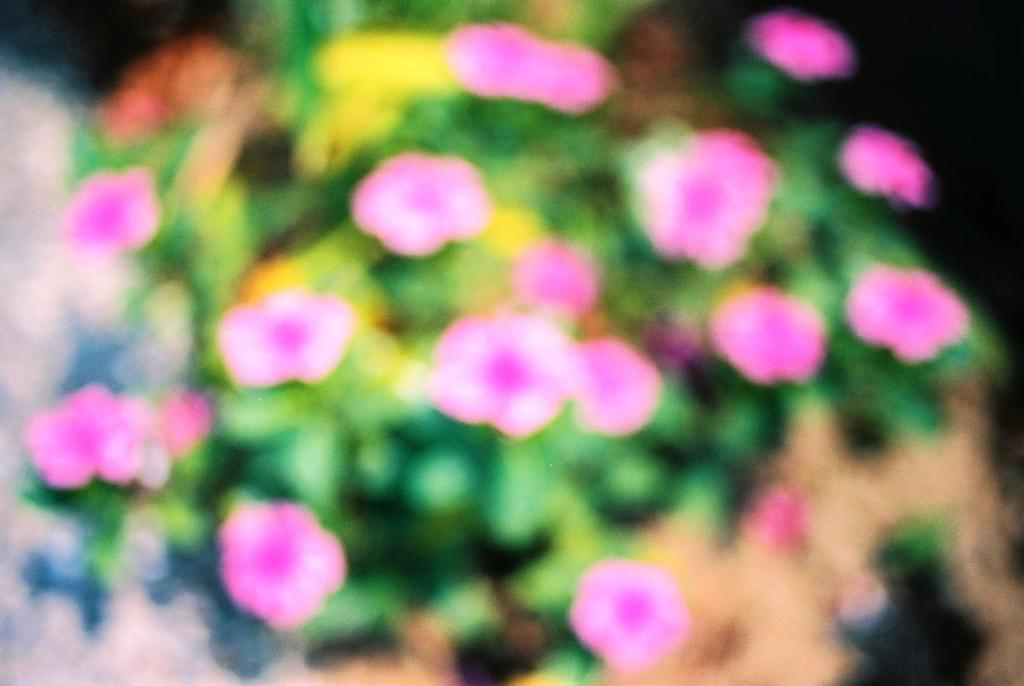What is present in the image? There is a plant in the image. What can be observed about the plant? The plant has flowers on it. What type of cast can be seen on the plant in the image? There is no cast present on the plant in the image. Is there a church visible in the background of the image? There is no mention of a church or any background in the provided facts, so it cannot be determined from the image. 